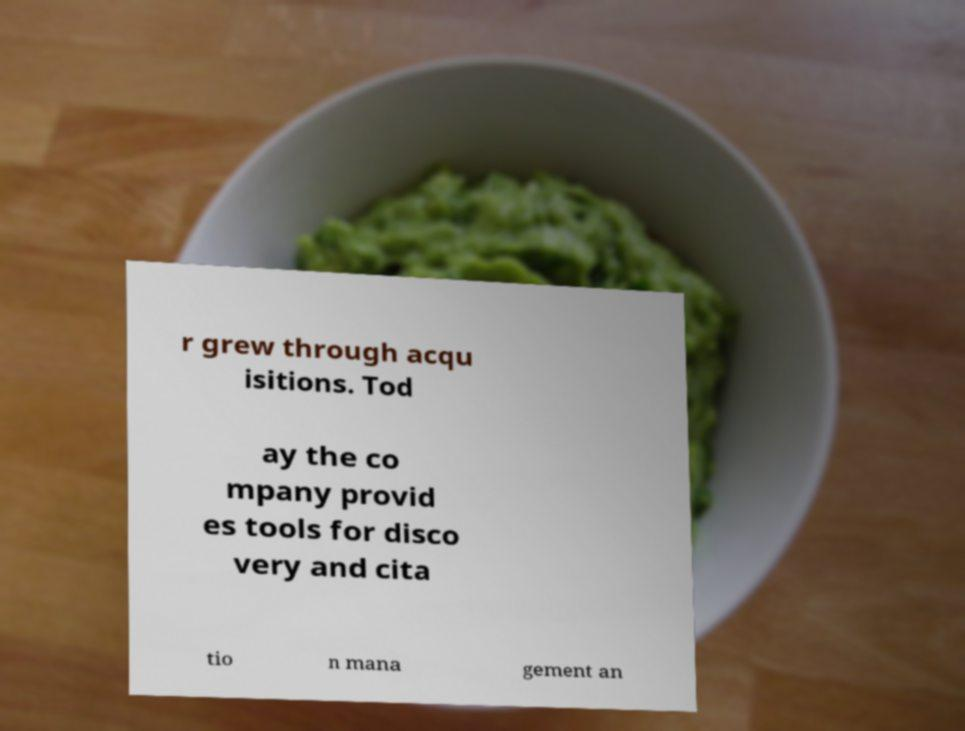Please identify and transcribe the text found in this image. r grew through acqu isitions. Tod ay the co mpany provid es tools for disco very and cita tio n mana gement an 